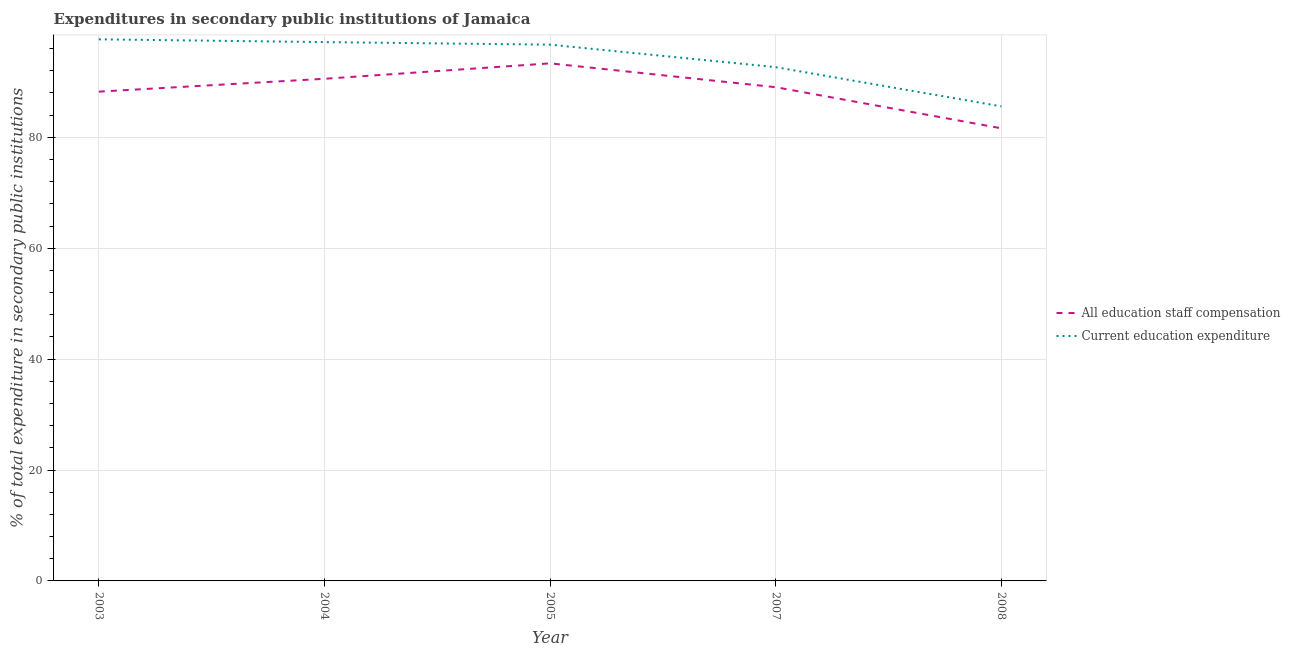How many different coloured lines are there?
Give a very brief answer. 2. Does the line corresponding to expenditure in staff compensation intersect with the line corresponding to expenditure in education?
Ensure brevity in your answer.  No. What is the expenditure in staff compensation in 2007?
Make the answer very short. 89.04. Across all years, what is the maximum expenditure in education?
Offer a very short reply. 97.68. Across all years, what is the minimum expenditure in staff compensation?
Offer a very short reply. 81.63. In which year was the expenditure in staff compensation minimum?
Keep it short and to the point. 2008. What is the total expenditure in education in the graph?
Keep it short and to the point. 469.82. What is the difference between the expenditure in education in 2003 and that in 2007?
Provide a short and direct response. 5.02. What is the difference between the expenditure in education in 2004 and the expenditure in staff compensation in 2007?
Your response must be concise. 8.14. What is the average expenditure in staff compensation per year?
Offer a very short reply. 88.57. In the year 2007, what is the difference between the expenditure in education and expenditure in staff compensation?
Your answer should be compact. 3.61. In how many years, is the expenditure in staff compensation greater than 92 %?
Provide a succinct answer. 1. What is the ratio of the expenditure in education in 2005 to that in 2007?
Your answer should be compact. 1.04. Is the difference between the expenditure in staff compensation in 2003 and 2004 greater than the difference between the expenditure in education in 2003 and 2004?
Offer a very short reply. No. What is the difference between the highest and the second highest expenditure in education?
Offer a very short reply. 0.5. What is the difference between the highest and the lowest expenditure in education?
Offer a very short reply. 12.1. Is the sum of the expenditure in staff compensation in 2005 and 2008 greater than the maximum expenditure in education across all years?
Your answer should be compact. Yes. Does the expenditure in education monotonically increase over the years?
Your answer should be compact. No. Is the expenditure in staff compensation strictly greater than the expenditure in education over the years?
Provide a succinct answer. No. How many years are there in the graph?
Provide a succinct answer. 5. What is the difference between two consecutive major ticks on the Y-axis?
Keep it short and to the point. 20. Are the values on the major ticks of Y-axis written in scientific E-notation?
Provide a succinct answer. No. Does the graph contain any zero values?
Keep it short and to the point. No. What is the title of the graph?
Provide a short and direct response. Expenditures in secondary public institutions of Jamaica. Does "GDP at market prices" appear as one of the legend labels in the graph?
Provide a short and direct response. No. What is the label or title of the Y-axis?
Your response must be concise. % of total expenditure in secondary public institutions. What is the % of total expenditure in secondary public institutions in All education staff compensation in 2003?
Make the answer very short. 88.24. What is the % of total expenditure in secondary public institutions in Current education expenditure in 2003?
Keep it short and to the point. 97.68. What is the % of total expenditure in secondary public institutions in All education staff compensation in 2004?
Provide a short and direct response. 90.56. What is the % of total expenditure in secondary public institutions of Current education expenditure in 2004?
Keep it short and to the point. 97.18. What is the % of total expenditure in secondary public institutions of All education staff compensation in 2005?
Keep it short and to the point. 93.34. What is the % of total expenditure in secondary public institutions of Current education expenditure in 2005?
Ensure brevity in your answer.  96.72. What is the % of total expenditure in secondary public institutions of All education staff compensation in 2007?
Offer a very short reply. 89.04. What is the % of total expenditure in secondary public institutions in Current education expenditure in 2007?
Provide a short and direct response. 92.66. What is the % of total expenditure in secondary public institutions in All education staff compensation in 2008?
Provide a short and direct response. 81.63. What is the % of total expenditure in secondary public institutions of Current education expenditure in 2008?
Offer a very short reply. 85.58. Across all years, what is the maximum % of total expenditure in secondary public institutions in All education staff compensation?
Keep it short and to the point. 93.34. Across all years, what is the maximum % of total expenditure in secondary public institutions in Current education expenditure?
Make the answer very short. 97.68. Across all years, what is the minimum % of total expenditure in secondary public institutions of All education staff compensation?
Provide a short and direct response. 81.63. Across all years, what is the minimum % of total expenditure in secondary public institutions in Current education expenditure?
Provide a succinct answer. 85.58. What is the total % of total expenditure in secondary public institutions of All education staff compensation in the graph?
Provide a succinct answer. 442.83. What is the total % of total expenditure in secondary public institutions of Current education expenditure in the graph?
Your answer should be compact. 469.82. What is the difference between the % of total expenditure in secondary public institutions of All education staff compensation in 2003 and that in 2004?
Your response must be concise. -2.32. What is the difference between the % of total expenditure in secondary public institutions of Current education expenditure in 2003 and that in 2004?
Ensure brevity in your answer.  0.5. What is the difference between the % of total expenditure in secondary public institutions of All education staff compensation in 2003 and that in 2005?
Make the answer very short. -5.1. What is the difference between the % of total expenditure in secondary public institutions of Current education expenditure in 2003 and that in 2005?
Offer a very short reply. 0.96. What is the difference between the % of total expenditure in secondary public institutions of All education staff compensation in 2003 and that in 2007?
Ensure brevity in your answer.  -0.8. What is the difference between the % of total expenditure in secondary public institutions in Current education expenditure in 2003 and that in 2007?
Offer a terse response. 5.02. What is the difference between the % of total expenditure in secondary public institutions in All education staff compensation in 2003 and that in 2008?
Offer a terse response. 6.61. What is the difference between the % of total expenditure in secondary public institutions of Current education expenditure in 2003 and that in 2008?
Ensure brevity in your answer.  12.1. What is the difference between the % of total expenditure in secondary public institutions of All education staff compensation in 2004 and that in 2005?
Your answer should be very brief. -2.78. What is the difference between the % of total expenditure in secondary public institutions of Current education expenditure in 2004 and that in 2005?
Your answer should be very brief. 0.46. What is the difference between the % of total expenditure in secondary public institutions of All education staff compensation in 2004 and that in 2007?
Your answer should be compact. 1.52. What is the difference between the % of total expenditure in secondary public institutions of Current education expenditure in 2004 and that in 2007?
Provide a short and direct response. 4.52. What is the difference between the % of total expenditure in secondary public institutions in All education staff compensation in 2004 and that in 2008?
Make the answer very short. 8.93. What is the difference between the % of total expenditure in secondary public institutions in Current education expenditure in 2004 and that in 2008?
Give a very brief answer. 11.6. What is the difference between the % of total expenditure in secondary public institutions of All education staff compensation in 2005 and that in 2007?
Give a very brief answer. 4.3. What is the difference between the % of total expenditure in secondary public institutions of Current education expenditure in 2005 and that in 2007?
Your response must be concise. 4.06. What is the difference between the % of total expenditure in secondary public institutions in All education staff compensation in 2005 and that in 2008?
Give a very brief answer. 11.71. What is the difference between the % of total expenditure in secondary public institutions in Current education expenditure in 2005 and that in 2008?
Make the answer very short. 11.13. What is the difference between the % of total expenditure in secondary public institutions of All education staff compensation in 2007 and that in 2008?
Make the answer very short. 7.41. What is the difference between the % of total expenditure in secondary public institutions in Current education expenditure in 2007 and that in 2008?
Your answer should be compact. 7.07. What is the difference between the % of total expenditure in secondary public institutions of All education staff compensation in 2003 and the % of total expenditure in secondary public institutions of Current education expenditure in 2004?
Your response must be concise. -8.94. What is the difference between the % of total expenditure in secondary public institutions of All education staff compensation in 2003 and the % of total expenditure in secondary public institutions of Current education expenditure in 2005?
Your answer should be very brief. -8.47. What is the difference between the % of total expenditure in secondary public institutions in All education staff compensation in 2003 and the % of total expenditure in secondary public institutions in Current education expenditure in 2007?
Give a very brief answer. -4.41. What is the difference between the % of total expenditure in secondary public institutions of All education staff compensation in 2003 and the % of total expenditure in secondary public institutions of Current education expenditure in 2008?
Make the answer very short. 2.66. What is the difference between the % of total expenditure in secondary public institutions in All education staff compensation in 2004 and the % of total expenditure in secondary public institutions in Current education expenditure in 2005?
Ensure brevity in your answer.  -6.15. What is the difference between the % of total expenditure in secondary public institutions in All education staff compensation in 2004 and the % of total expenditure in secondary public institutions in Current education expenditure in 2007?
Your response must be concise. -2.09. What is the difference between the % of total expenditure in secondary public institutions in All education staff compensation in 2004 and the % of total expenditure in secondary public institutions in Current education expenditure in 2008?
Offer a terse response. 4.98. What is the difference between the % of total expenditure in secondary public institutions of All education staff compensation in 2005 and the % of total expenditure in secondary public institutions of Current education expenditure in 2007?
Keep it short and to the point. 0.69. What is the difference between the % of total expenditure in secondary public institutions in All education staff compensation in 2005 and the % of total expenditure in secondary public institutions in Current education expenditure in 2008?
Your response must be concise. 7.76. What is the difference between the % of total expenditure in secondary public institutions in All education staff compensation in 2007 and the % of total expenditure in secondary public institutions in Current education expenditure in 2008?
Offer a terse response. 3.46. What is the average % of total expenditure in secondary public institutions of All education staff compensation per year?
Offer a very short reply. 88.57. What is the average % of total expenditure in secondary public institutions in Current education expenditure per year?
Keep it short and to the point. 93.96. In the year 2003, what is the difference between the % of total expenditure in secondary public institutions in All education staff compensation and % of total expenditure in secondary public institutions in Current education expenditure?
Your answer should be very brief. -9.44. In the year 2004, what is the difference between the % of total expenditure in secondary public institutions in All education staff compensation and % of total expenditure in secondary public institutions in Current education expenditure?
Your answer should be very brief. -6.62. In the year 2005, what is the difference between the % of total expenditure in secondary public institutions in All education staff compensation and % of total expenditure in secondary public institutions in Current education expenditure?
Provide a short and direct response. -3.37. In the year 2007, what is the difference between the % of total expenditure in secondary public institutions in All education staff compensation and % of total expenditure in secondary public institutions in Current education expenditure?
Offer a very short reply. -3.61. In the year 2008, what is the difference between the % of total expenditure in secondary public institutions in All education staff compensation and % of total expenditure in secondary public institutions in Current education expenditure?
Your answer should be compact. -3.95. What is the ratio of the % of total expenditure in secondary public institutions of All education staff compensation in 2003 to that in 2004?
Provide a succinct answer. 0.97. What is the ratio of the % of total expenditure in secondary public institutions of All education staff compensation in 2003 to that in 2005?
Offer a terse response. 0.95. What is the ratio of the % of total expenditure in secondary public institutions in Current education expenditure in 2003 to that in 2005?
Give a very brief answer. 1.01. What is the ratio of the % of total expenditure in secondary public institutions of Current education expenditure in 2003 to that in 2007?
Make the answer very short. 1.05. What is the ratio of the % of total expenditure in secondary public institutions of All education staff compensation in 2003 to that in 2008?
Offer a very short reply. 1.08. What is the ratio of the % of total expenditure in secondary public institutions of Current education expenditure in 2003 to that in 2008?
Make the answer very short. 1.14. What is the ratio of the % of total expenditure in secondary public institutions of All education staff compensation in 2004 to that in 2005?
Give a very brief answer. 0.97. What is the ratio of the % of total expenditure in secondary public institutions in Current education expenditure in 2004 to that in 2005?
Provide a succinct answer. 1. What is the ratio of the % of total expenditure in secondary public institutions in All education staff compensation in 2004 to that in 2007?
Provide a succinct answer. 1.02. What is the ratio of the % of total expenditure in secondary public institutions of Current education expenditure in 2004 to that in 2007?
Make the answer very short. 1.05. What is the ratio of the % of total expenditure in secondary public institutions of All education staff compensation in 2004 to that in 2008?
Make the answer very short. 1.11. What is the ratio of the % of total expenditure in secondary public institutions of Current education expenditure in 2004 to that in 2008?
Offer a very short reply. 1.14. What is the ratio of the % of total expenditure in secondary public institutions in All education staff compensation in 2005 to that in 2007?
Your answer should be very brief. 1.05. What is the ratio of the % of total expenditure in secondary public institutions of Current education expenditure in 2005 to that in 2007?
Provide a succinct answer. 1.04. What is the ratio of the % of total expenditure in secondary public institutions in All education staff compensation in 2005 to that in 2008?
Your answer should be very brief. 1.14. What is the ratio of the % of total expenditure in secondary public institutions in Current education expenditure in 2005 to that in 2008?
Keep it short and to the point. 1.13. What is the ratio of the % of total expenditure in secondary public institutions in All education staff compensation in 2007 to that in 2008?
Provide a succinct answer. 1.09. What is the ratio of the % of total expenditure in secondary public institutions in Current education expenditure in 2007 to that in 2008?
Provide a short and direct response. 1.08. What is the difference between the highest and the second highest % of total expenditure in secondary public institutions of All education staff compensation?
Provide a succinct answer. 2.78. What is the difference between the highest and the second highest % of total expenditure in secondary public institutions of Current education expenditure?
Provide a succinct answer. 0.5. What is the difference between the highest and the lowest % of total expenditure in secondary public institutions of All education staff compensation?
Your answer should be compact. 11.71. What is the difference between the highest and the lowest % of total expenditure in secondary public institutions of Current education expenditure?
Give a very brief answer. 12.1. 